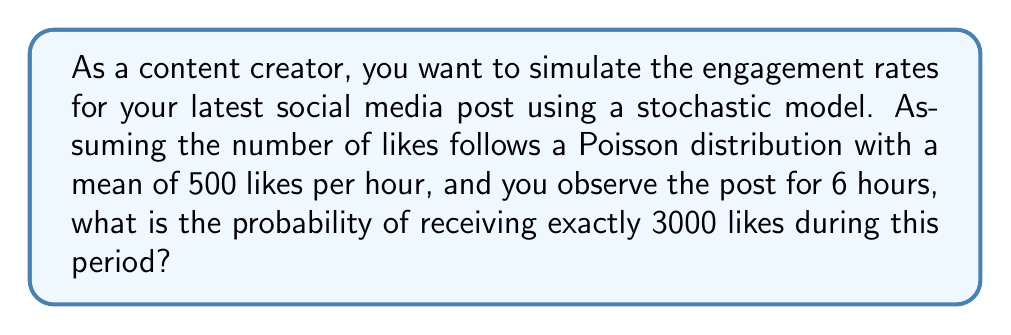Teach me how to tackle this problem. To solve this problem, we'll use the Poisson distribution formula and follow these steps:

1) The Poisson distribution is given by:

   $$P(X = k) = \frac{e^{-\lambda} \lambda^k}{k!}$$

   where $\lambda$ is the expected number of events in the given time period, and $k$ is the number of events we're interested in.

2) In this case:
   - $\lambda = 500 \text{ likes/hour} \times 6 \text{ hours} = 3000 \text{ likes}$
   - $k = 3000 \text{ likes}$

3) Substituting these values into the formula:

   $$P(X = 3000) = \frac{e^{-3000} 3000^{3000}}{3000!}$$

4) This calculation is complex due to the large numbers involved. We can simplify it using Stirling's approximation for factorials:

   $$n! \approx \sqrt{2\pi n} \left(\frac{n}{e}\right)^n$$

5) Applying this to our equation:

   $$P(X = 3000) \approx \frac{e^{-3000} 3000^{3000}}{\sqrt{2\pi 3000} \left(\frac{3000}{e}\right)^{3000}}$$

6) Simplifying:

   $$P(X = 3000) \approx \frac{1}{\sqrt{2\pi 3000}} \approx 0.007303$$

7) Converting to a percentage:

   $$0.007303 \times 100\% \approx 0.7303\%$$
Answer: 0.7303% 